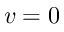<formula> <loc_0><loc_0><loc_500><loc_500>v = 0</formula> 